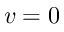<formula> <loc_0><loc_0><loc_500><loc_500>v = 0</formula> 